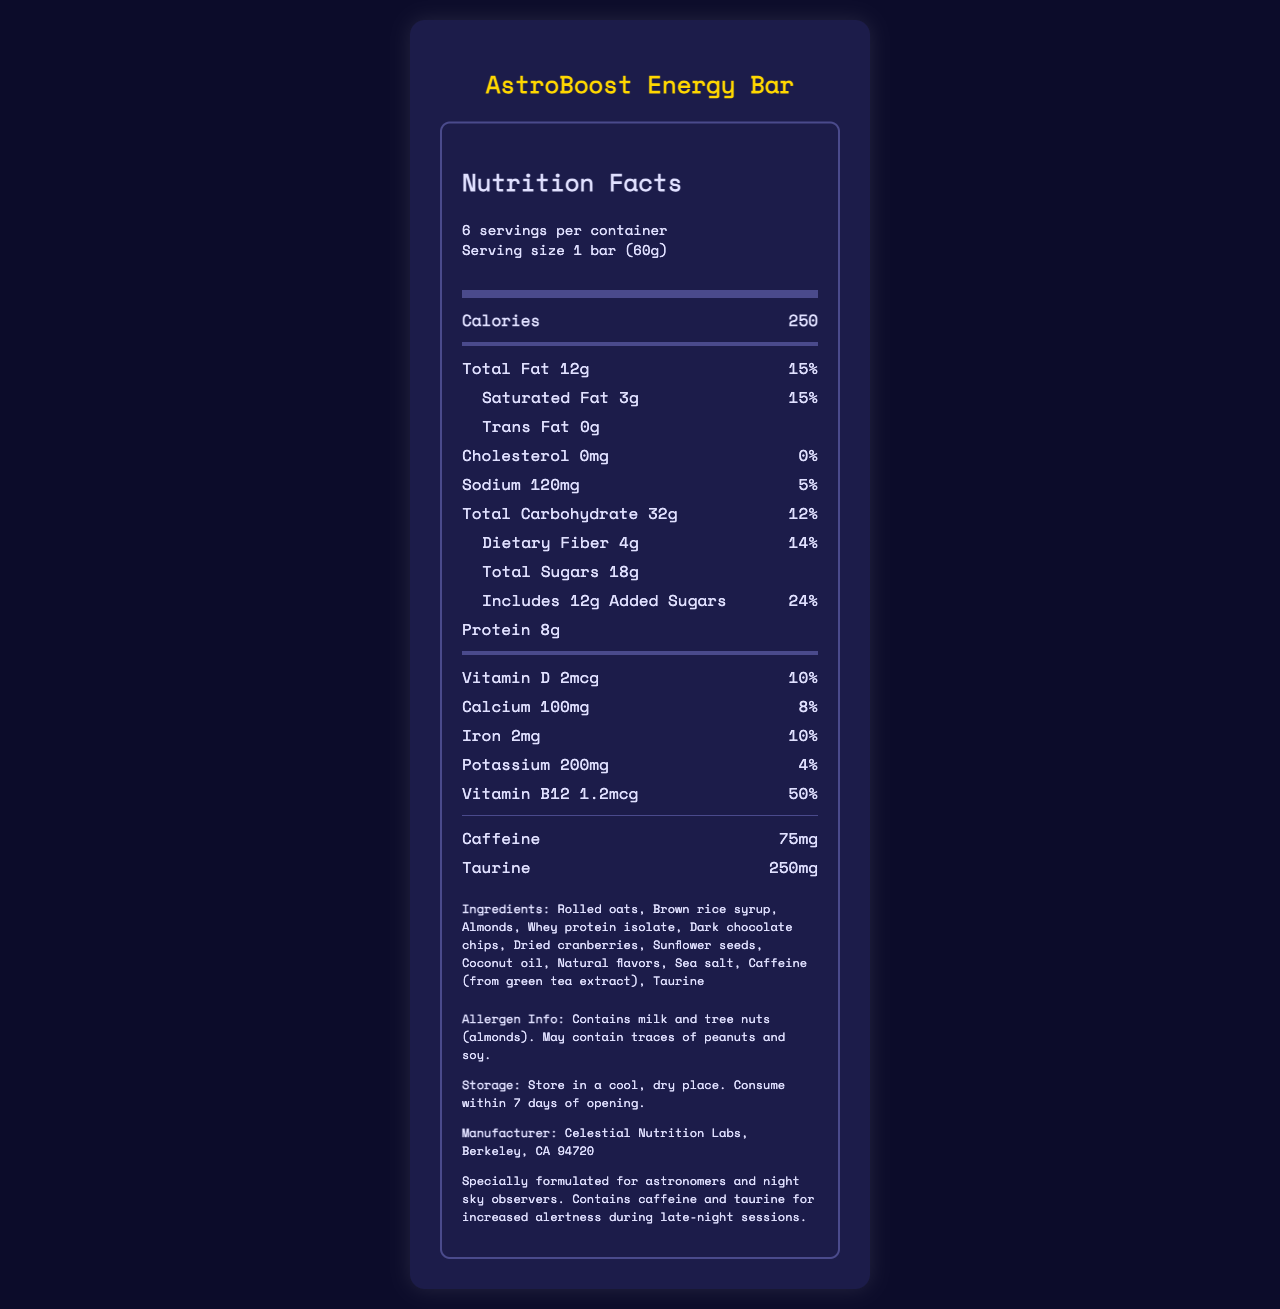what is the serving size? The serving size is explicitly listed as "1 bar (60g)" in the document.
Answer: 1 bar (60g) how many servings per container? The document mentions "6 servings per container."
Answer: 6 How many calories are in one AstroBoost Energy Bar? The nutrition label states that one serving, which is one bar, contains 250 calories.
Answer: 250 what is the total fat content in one bar? The total fat content is listed as "12g" in the nutrient section of the document.
Answer: 12g what is the percentage daily value of saturated fat? The saturated fat daily value is listed as "15%" right beside its amount (3g).
Answer: 15% What is the protein content in one serving of this energy bar? The nutrient section clearly states there is 8g of protein per bar.
Answer: 8g How much dietary fiber does one bar contain? The dietary fiber content is listed as "4g" in the document.
Answer: 4g How much added sugar does one serving include? A. 6g B. 12g C. 18g The document states that there are 12g of added sugars per serving.
Answer: B What is the caffeine content in each bar? A. 50mg B. 75mg C. 100mg D. 125mg The document mentions a caffeine content of 75mg.
Answer: B Does this product contain any trans fat? The document clearly states "Trans Fat 0g," which means it contains no trans fat.
Answer: No is there any cholesterol in the AstroBoost Energy Bar? According to the document, the cholesterol amount is "0mg," indicating none.
Answer: No Summarize the information presented in the nutrition facts label. The document provides comprehensive nutritional information about the AstroBoost Energy Bar, highlighting its utility for astronomers with additional ingredients like caffeine and taurine for alertness.
Answer: The document provides a detailed nutrition facts label for the "AstroBoost Energy Bar." It includes serving size (1 bar, 60g), servings per container (6), and calories per serving (250). It lists the amounts and daily values of various nutrients including total fat (12g, 15%), saturated fat (3g, 15%), trans fat (0g), cholesterol (0mg, 0%), sodium (120mg, 5%), total carbohydrate (32g, 12%), dietary fiber (4g, 14%), total sugars (18g including 12g of added sugars, 24%), protein (8g), vitamin D (2mcg, 10%), calcium (100mg, 8%), iron (2mg, 10%), potassium (200mg, 4%), and vitamin B12 (1.2mcg, 50%). It also contains caffeine (75mg) and taurine (250mg). The ingredients are listed, along with allergen information, storage instructions, manufacturer details, and additional info tailored to astronomers and night sky observers. what is the source of caffeine in the energy bar? The ingredient list specifies that caffeine comes from green tea extract.
Answer: Green tea extract what percentage of the daily value of vitamin B12 is in one serving of this energy bar? The document lists the amount of vitamin B12 as "1.2mcg" and "50%" of the daily value.
Answer: 50% How many grams of total sugars are in the energy bar, including added sugars? The document states the total sugars as 18g, with 12g being added sugars.
Answer: 18g Can we determine the manufacturing date from this document? The document does not provide any details regarding the manufacturing date.
Answer: Not enough information 